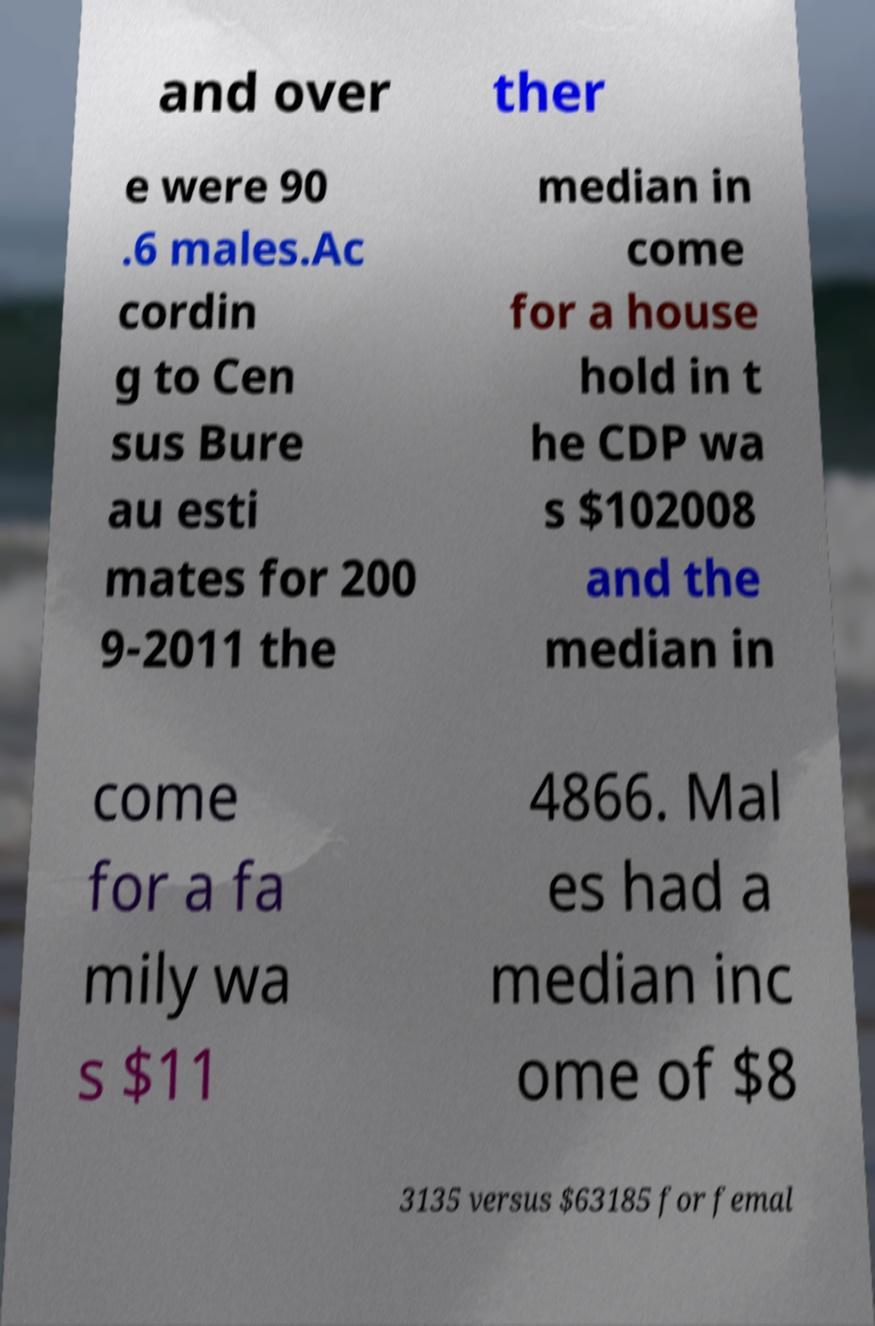What messages or text are displayed in this image? I need them in a readable, typed format. and over ther e were 90 .6 males.Ac cordin g to Cen sus Bure au esti mates for 200 9-2011 the median in come for a house hold in t he CDP wa s $102008 and the median in come for a fa mily wa s $11 4866. Mal es had a median inc ome of $8 3135 versus $63185 for femal 